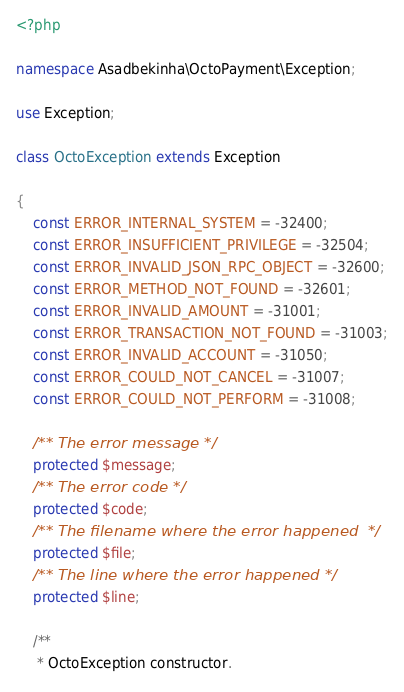Convert code to text. <code><loc_0><loc_0><loc_500><loc_500><_PHP_><?php

namespace Asadbekinha\OctoPayment\Exception;

use Exception;

class OctoException extends Exception

{
    const ERROR_INTERNAL_SYSTEM = -32400;
    const ERROR_INSUFFICIENT_PRIVILEGE = -32504;
    const ERROR_INVALID_JSON_RPC_OBJECT = -32600;
    const ERROR_METHOD_NOT_FOUND = -32601;
    const ERROR_INVALID_AMOUNT = -31001;
    const ERROR_TRANSACTION_NOT_FOUND = -31003;
    const ERROR_INVALID_ACCOUNT = -31050;
    const ERROR_COULD_NOT_CANCEL = -31007;
    const ERROR_COULD_NOT_PERFORM = -31008;

    /** The error message */
    protected $message;
    /** The error code */
    protected $code;
    /** The filename where the error happened  */
    protected $file;
    /** The line where the error happened */
    protected $line;

    /**
     * OctoException constructor.</code> 